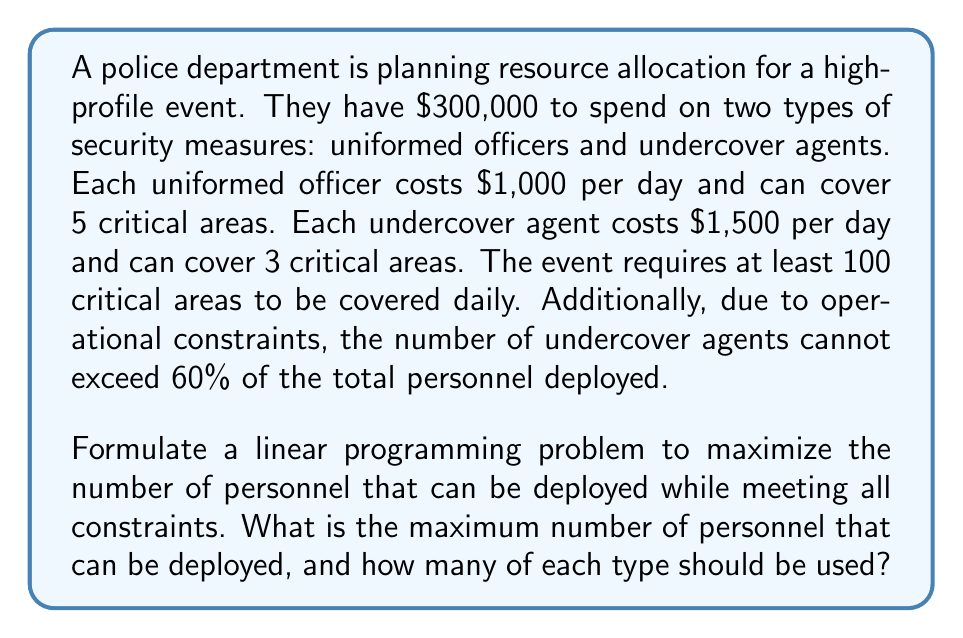Solve this math problem. Let's approach this step-by-step using linear programming:

1) Define variables:
   Let $x$ = number of uniformed officers
   Let $y$ = number of undercover agents

2) Objective function:
   We want to maximize the total number of personnel:
   Maximize $z = x + y$

3) Constraints:
   a) Budget constraint:
      $1000x + 1500y \leq 300000$

   b) Coverage constraint:
      $5x + 3y \geq 100$

   c) Operational constraint:
      $y \leq 0.6(x + y)$, which simplifies to $y \leq 1.5x$

   d) Non-negativity:
      $x \geq 0, y \geq 0$

4) Solve graphically or using the simplex method. The feasible region is bounded by these constraints, and the optimal solution will be at one of the corners of this region.

5) The corners of the feasible region can be found by solving the equations in pairs:

   From (a) and (b): 
   $x = 240, y = 40$

   From (a) and (c):
   $x = 200, y = 100$

   From (b) and (c):
   $x = 20, y = 30$

6) Evaluating $z = x + y$ at these points:
   $(240, 40): z = 280$
   $(200, 100): z = 300$
   $(20, 30): z = 50$

7) The maximum value of $z$ is 300, occurring at $x = 200, y = 100$.

Therefore, the optimal solution is to deploy 200 uniformed officers and 100 undercover agents, for a total of 300 personnel.
Answer: The maximum number of personnel that can be deployed is 300, consisting of 200 uniformed officers and 100 undercover agents. 